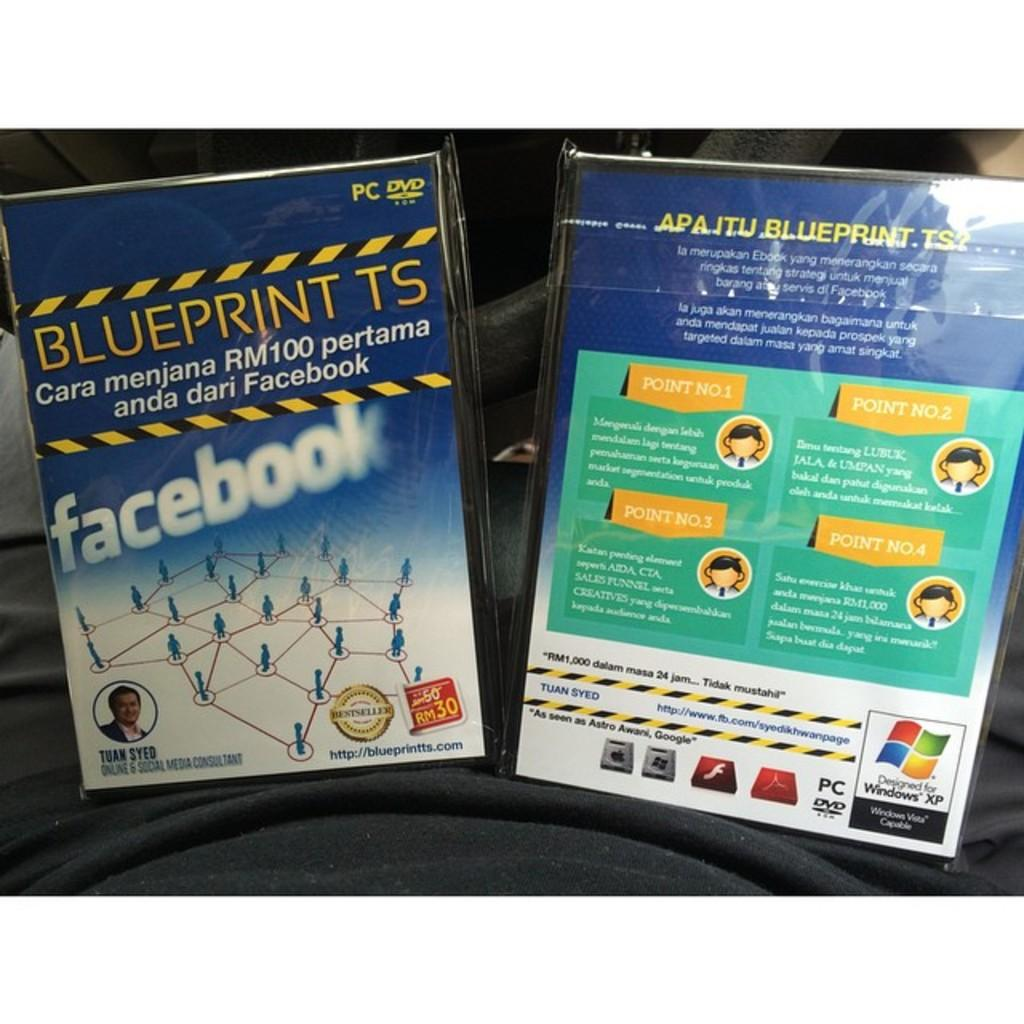<image>
Summarize the visual content of the image. a PC DVD front and back cover for facebook blueprint 